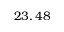<formula> <loc_0><loc_0><loc_500><loc_500>2 3 , 4 8</formula> 